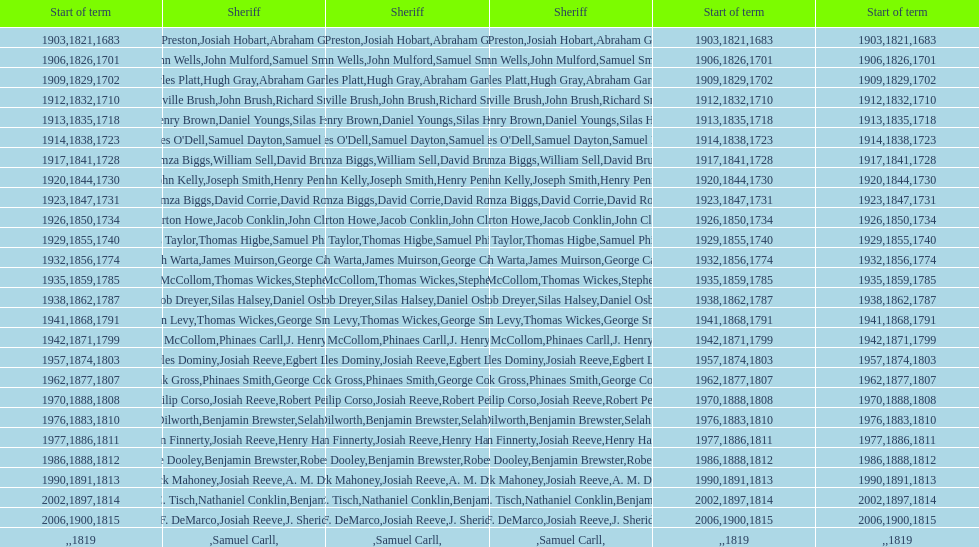Who was the sheriff prior to thomas wickes? James Muirson. 